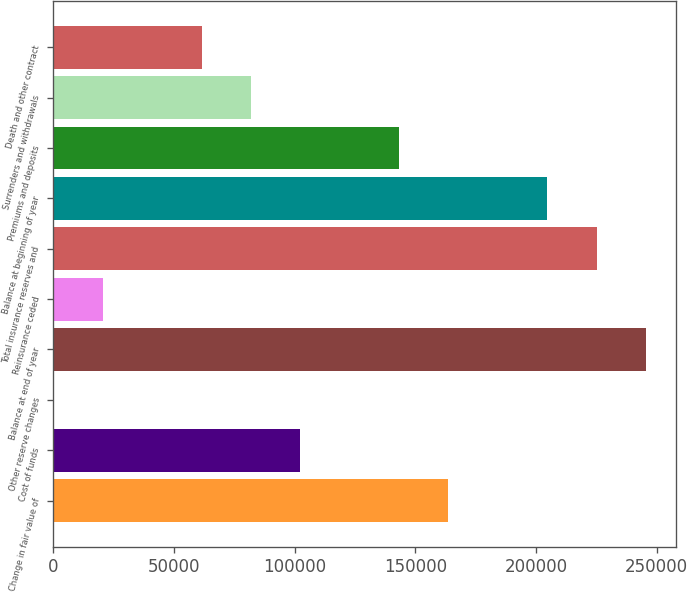Convert chart. <chart><loc_0><loc_0><loc_500><loc_500><bar_chart><fcel>Change in fair value of<fcel>Cost of funds<fcel>Other reserve changes<fcel>Balance at end of year<fcel>Reinsurance ceded<fcel>Total insurance reserves and<fcel>Balance at beginning of year<fcel>Premiums and deposits<fcel>Surrenders and withdrawals<fcel>Death and other contract<nl><fcel>163718<fcel>102354<fcel>80<fcel>245536<fcel>20534.7<fcel>225082<fcel>204627<fcel>143263<fcel>81898.8<fcel>61444.1<nl></chart> 